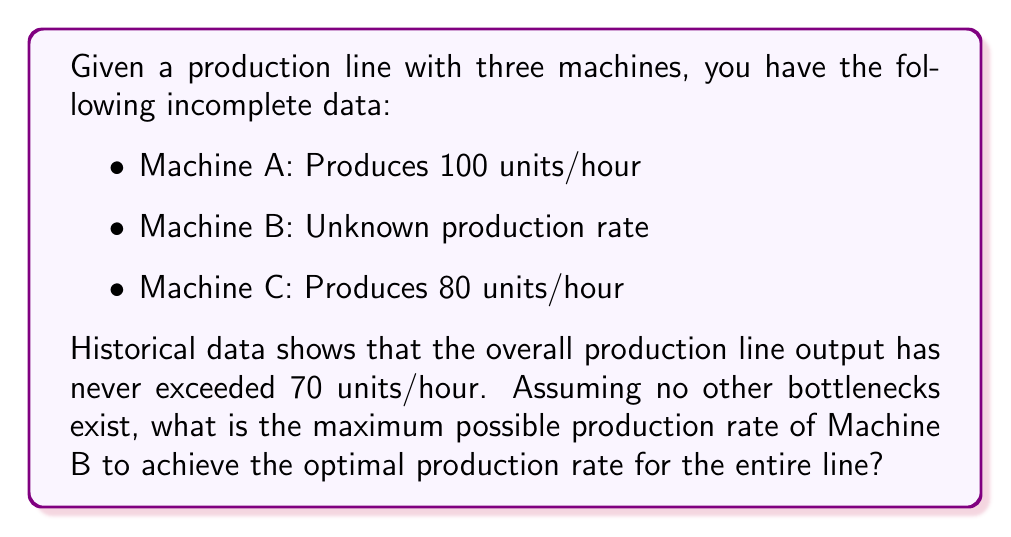Give your solution to this math problem. To solve this inverse problem and determine the optimal production rate given incomplete data, we'll follow these steps:

1) First, we need to understand that the production line's output is limited by its slowest machine. This is known as the bottleneck principle.

2) We know that Machine A can produce 100 units/hour and Machine C can produce 80 units/hour. If Machine B were faster than both of these, the line would be limited to 80 units/hour (the slower of A and C).

3) However, we're told that the overall production line output has never exceeded 70 units/hour. This means that Machine B must be the bottleneck, producing less than 80 units/hour.

4) To optimize the production rate, Machine B should produce exactly 70 units/hour. Any faster would be wasted capacity (as the line can't exceed 70 units/hour), and any slower would reduce overall output.

5) We can express this mathematically as:

   $$\text{Optimal Production Rate} = \min(R_A, R_B, R_C)$$

   Where $R_A$, $R_B$, and $R_C$ are the rates of Machines A, B, and C respectively.

6) Given our data:
   
   $$70 = \min(100, R_B, 80)$$

7) Solving this equation, we find that $R_B$ must equal 70 for the equation to hold true.

Therefore, the maximum possible production rate of Machine B to achieve the optimal production rate for the entire line is 70 units/hour.
Answer: 70 units/hour 